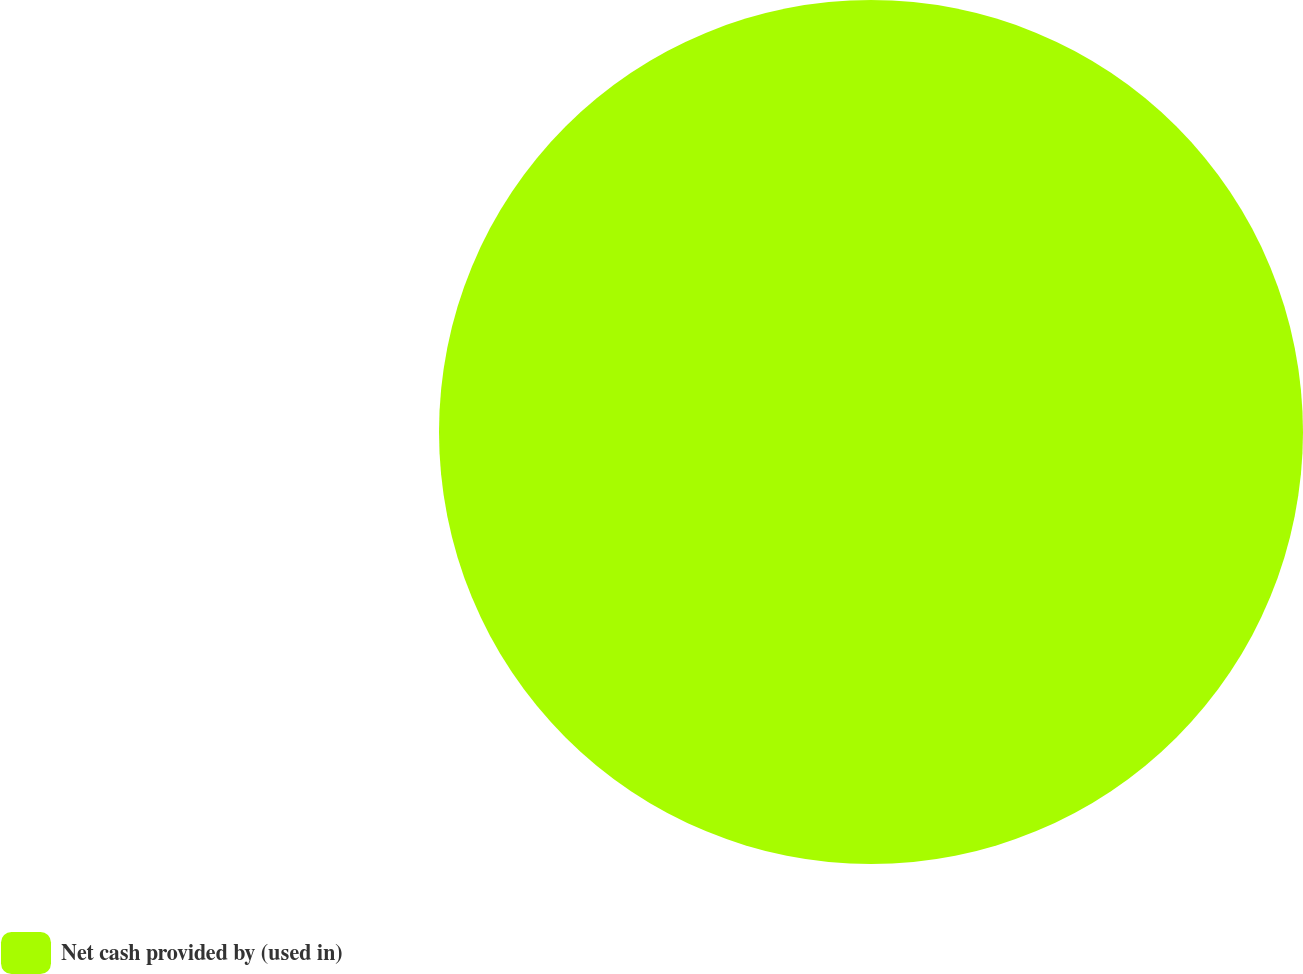Convert chart to OTSL. <chart><loc_0><loc_0><loc_500><loc_500><pie_chart><fcel>Net cash provided by (used in)<nl><fcel>100.0%<nl></chart> 